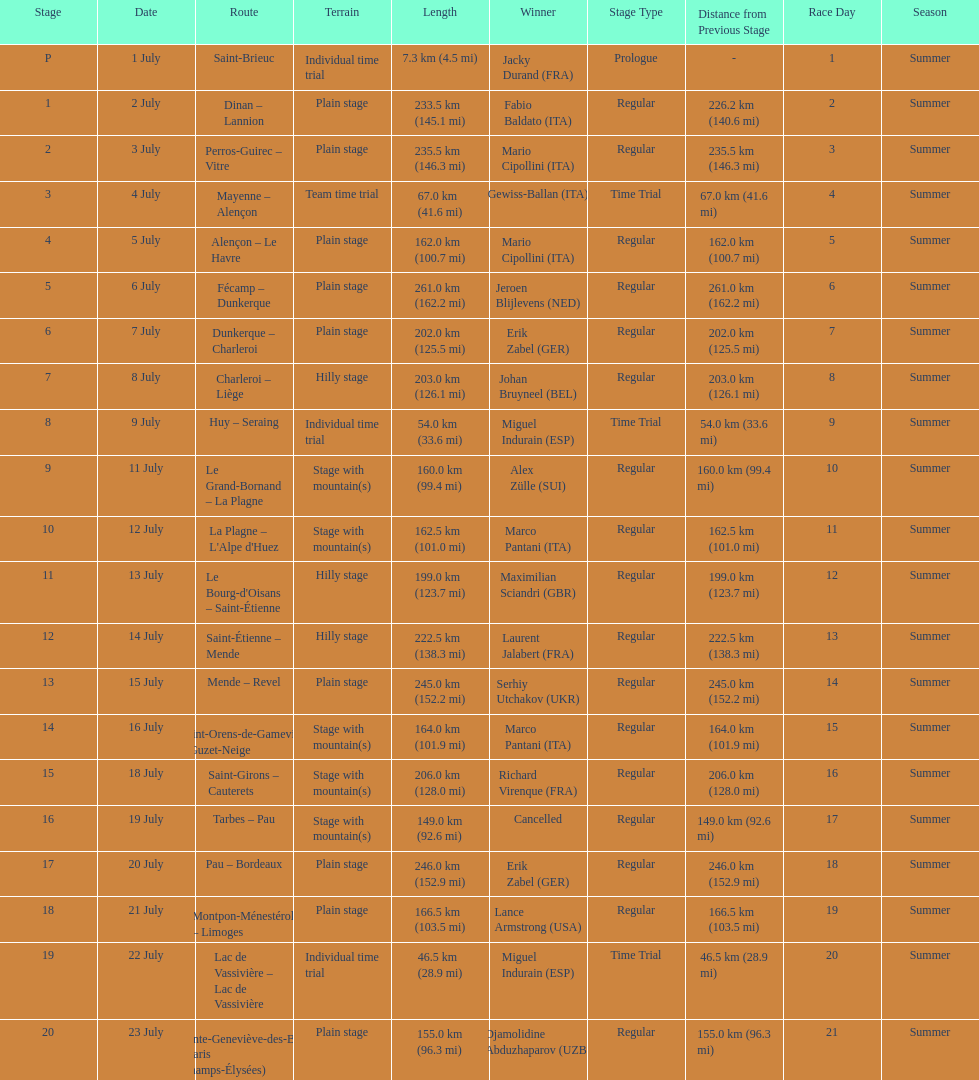Parse the table in full. {'header': ['Stage', 'Date', 'Route', 'Terrain', 'Length', 'Winner', 'Stage Type', 'Distance from Previous Stage', 'Race Day', 'Season'], 'rows': [['P', '1 July', 'Saint-Brieuc', 'Individual time trial', '7.3\xa0km (4.5\xa0mi)', 'Jacky Durand\xa0(FRA)', 'Prologue', '-', '1', 'Summer'], ['1', '2 July', 'Dinan – Lannion', 'Plain stage', '233.5\xa0km (145.1\xa0mi)', 'Fabio Baldato\xa0(ITA)', 'Regular', '226.2 km (140.6 mi)', '2', 'Summer'], ['2', '3 July', 'Perros-Guirec – Vitre', 'Plain stage', '235.5\xa0km (146.3\xa0mi)', 'Mario Cipollini\xa0(ITA)', 'Regular', '235.5 km (146.3 mi)', '3', 'Summer'], ['3', '4 July', 'Mayenne – Alençon', 'Team time trial', '67.0\xa0km (41.6\xa0mi)', 'Gewiss-Ballan\xa0(ITA)', 'Time Trial', '67.0 km (41.6 mi)', '4', 'Summer'], ['4', '5 July', 'Alençon – Le Havre', 'Plain stage', '162.0\xa0km (100.7\xa0mi)', 'Mario Cipollini\xa0(ITA)', 'Regular', '162.0 km (100.7 mi)', '5', 'Summer'], ['5', '6 July', 'Fécamp – Dunkerque', 'Plain stage', '261.0\xa0km (162.2\xa0mi)', 'Jeroen Blijlevens\xa0(NED)', 'Regular', '261.0 km (162.2 mi)', '6', 'Summer'], ['6', '7 July', 'Dunkerque – Charleroi', 'Plain stage', '202.0\xa0km (125.5\xa0mi)', 'Erik Zabel\xa0(GER)', 'Regular', '202.0 km (125.5 mi)', '7', 'Summer'], ['7', '8 July', 'Charleroi – Liège', 'Hilly stage', '203.0\xa0km (126.1\xa0mi)', 'Johan Bruyneel\xa0(BEL)', 'Regular', '203.0 km (126.1 mi)', '8', 'Summer'], ['8', '9 July', 'Huy – Seraing', 'Individual time trial', '54.0\xa0km (33.6\xa0mi)', 'Miguel Indurain\xa0(ESP)', 'Time Trial', '54.0 km (33.6 mi)', '9', 'Summer'], ['9', '11 July', 'Le Grand-Bornand – La Plagne', 'Stage with mountain(s)', '160.0\xa0km (99.4\xa0mi)', 'Alex Zülle\xa0(SUI)', 'Regular', '160.0 km (99.4 mi)', '10', 'Summer'], ['10', '12 July', "La Plagne – L'Alpe d'Huez", 'Stage with mountain(s)', '162.5\xa0km (101.0\xa0mi)', 'Marco Pantani\xa0(ITA)', 'Regular', '162.5 km (101.0 mi)', '11', 'Summer'], ['11', '13 July', "Le Bourg-d'Oisans – Saint-Étienne", 'Hilly stage', '199.0\xa0km (123.7\xa0mi)', 'Maximilian Sciandri\xa0(GBR)', 'Regular', '199.0 km (123.7 mi)', '12', 'Summer'], ['12', '14 July', 'Saint-Étienne – Mende', 'Hilly stage', '222.5\xa0km (138.3\xa0mi)', 'Laurent Jalabert\xa0(FRA)', 'Regular', '222.5 km (138.3 mi)', '13', 'Summer'], ['13', '15 July', 'Mende – Revel', 'Plain stage', '245.0\xa0km (152.2\xa0mi)', 'Serhiy Utchakov\xa0(UKR)', 'Regular', '245.0 km (152.2 mi)', '14', 'Summer'], ['14', '16 July', 'Saint-Orens-de-Gameville – Guzet-Neige', 'Stage with mountain(s)', '164.0\xa0km (101.9\xa0mi)', 'Marco Pantani\xa0(ITA)', 'Regular', '164.0 km (101.9 mi)', '15', 'Summer'], ['15', '18 July', 'Saint-Girons – Cauterets', 'Stage with mountain(s)', '206.0\xa0km (128.0\xa0mi)', 'Richard Virenque\xa0(FRA)', 'Regular', '206.0 km (128.0 mi)', '16', 'Summer'], ['16', '19 July', 'Tarbes – Pau', 'Stage with mountain(s)', '149.0\xa0km (92.6\xa0mi)', 'Cancelled', 'Regular', '149.0 km (92.6 mi)', '17', 'Summer'], ['17', '20 July', 'Pau – Bordeaux', 'Plain stage', '246.0\xa0km (152.9\xa0mi)', 'Erik Zabel\xa0(GER)', 'Regular', '246.0 km (152.9 mi)', '18', 'Summer'], ['18', '21 July', 'Montpon-Ménestérol – Limoges', 'Plain stage', '166.5\xa0km (103.5\xa0mi)', 'Lance Armstrong\xa0(USA)', 'Regular', '166.5 km (103.5 mi)', '19', 'Summer'], ['19', '22 July', 'Lac de Vassivière – Lac de Vassivière', 'Individual time trial', '46.5\xa0km (28.9\xa0mi)', 'Miguel Indurain\xa0(ESP)', 'Time Trial', '46.5 km (28.9 mi)', '20', 'Summer'], ['20', '23 July', 'Sainte-Geneviève-des-Bois – Paris (Champs-Élysées)', 'Plain stage', '155.0\xa0km (96.3\xa0mi)', 'Djamolidine Abduzhaparov\xa0(UZB)', 'Regular', '155.0 km (96.3 mi)', '21', 'Summer']]} How many routes have below 100 km total? 4. 